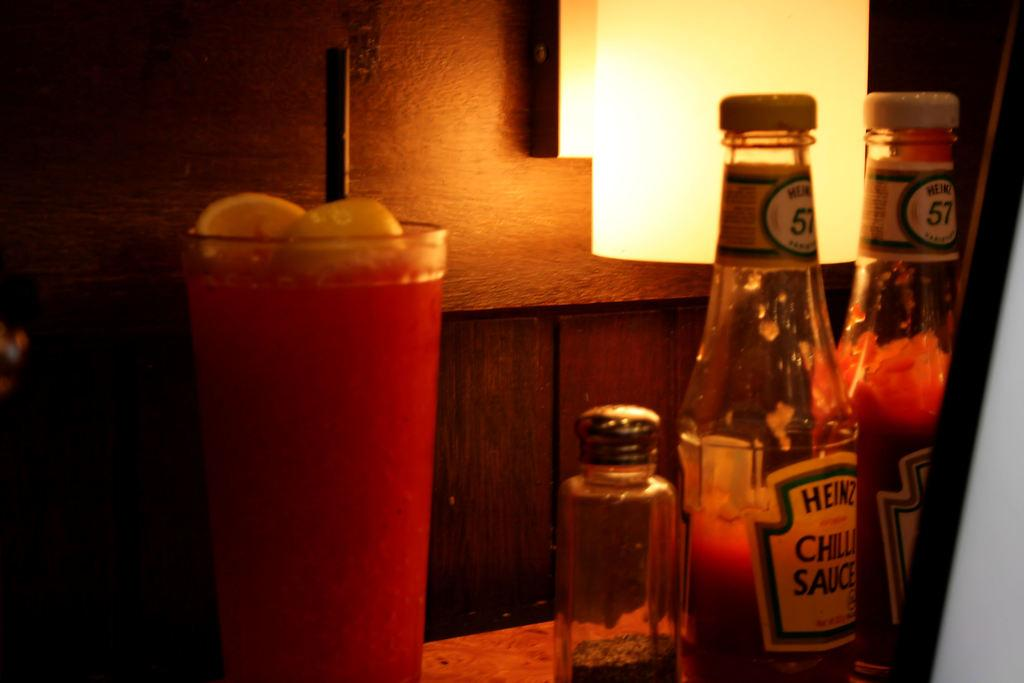<image>
Write a terse but informative summary of the picture. A drink on a table beside a pepper shaker and Heinz ketchup. 